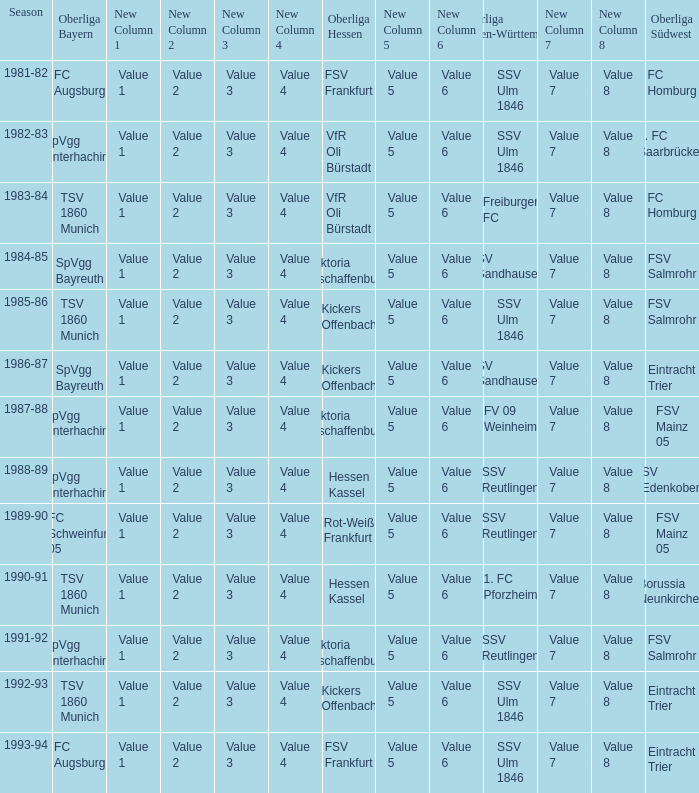Which Oberliga Baden-Württemberg has an Oberliga Hessen of fsv frankfurt in 1993-94? SSV Ulm 1846. 